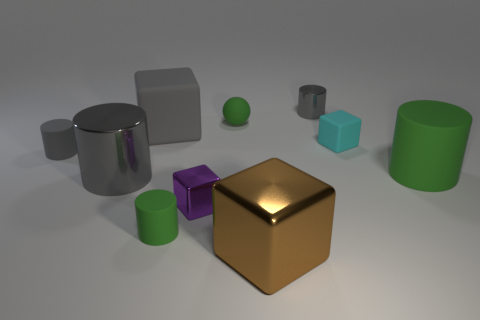There is a small gray object that is to the right of the brown shiny cube; is its shape the same as the small gray object that is on the left side of the big gray metallic thing?
Provide a short and direct response. Yes. How many objects are small matte cylinders or small objects behind the gray matte cylinder?
Your response must be concise. 5. What is the tiny cylinder that is behind the large green thing and on the left side of the purple metal object made of?
Keep it short and to the point. Rubber. What color is the ball that is made of the same material as the large green object?
Your response must be concise. Green. What number of objects are either tiny green balls or brown cubes?
Ensure brevity in your answer.  2. Is the size of the brown shiny object the same as the gray metallic thing to the left of the small green matte cylinder?
Ensure brevity in your answer.  Yes. There is a rubber cylinder to the right of the small matte cylinder that is to the right of the rubber cylinder behind the big green cylinder; what color is it?
Your answer should be very brief. Green. The large metallic block has what color?
Offer a terse response. Brown. Is the number of green matte cylinders that are on the right side of the tiny cyan object greater than the number of tiny green rubber cylinders behind the big brown block?
Your answer should be very brief. No. There is a tiny gray rubber thing; does it have the same shape as the metallic object left of the large matte block?
Keep it short and to the point. Yes. 